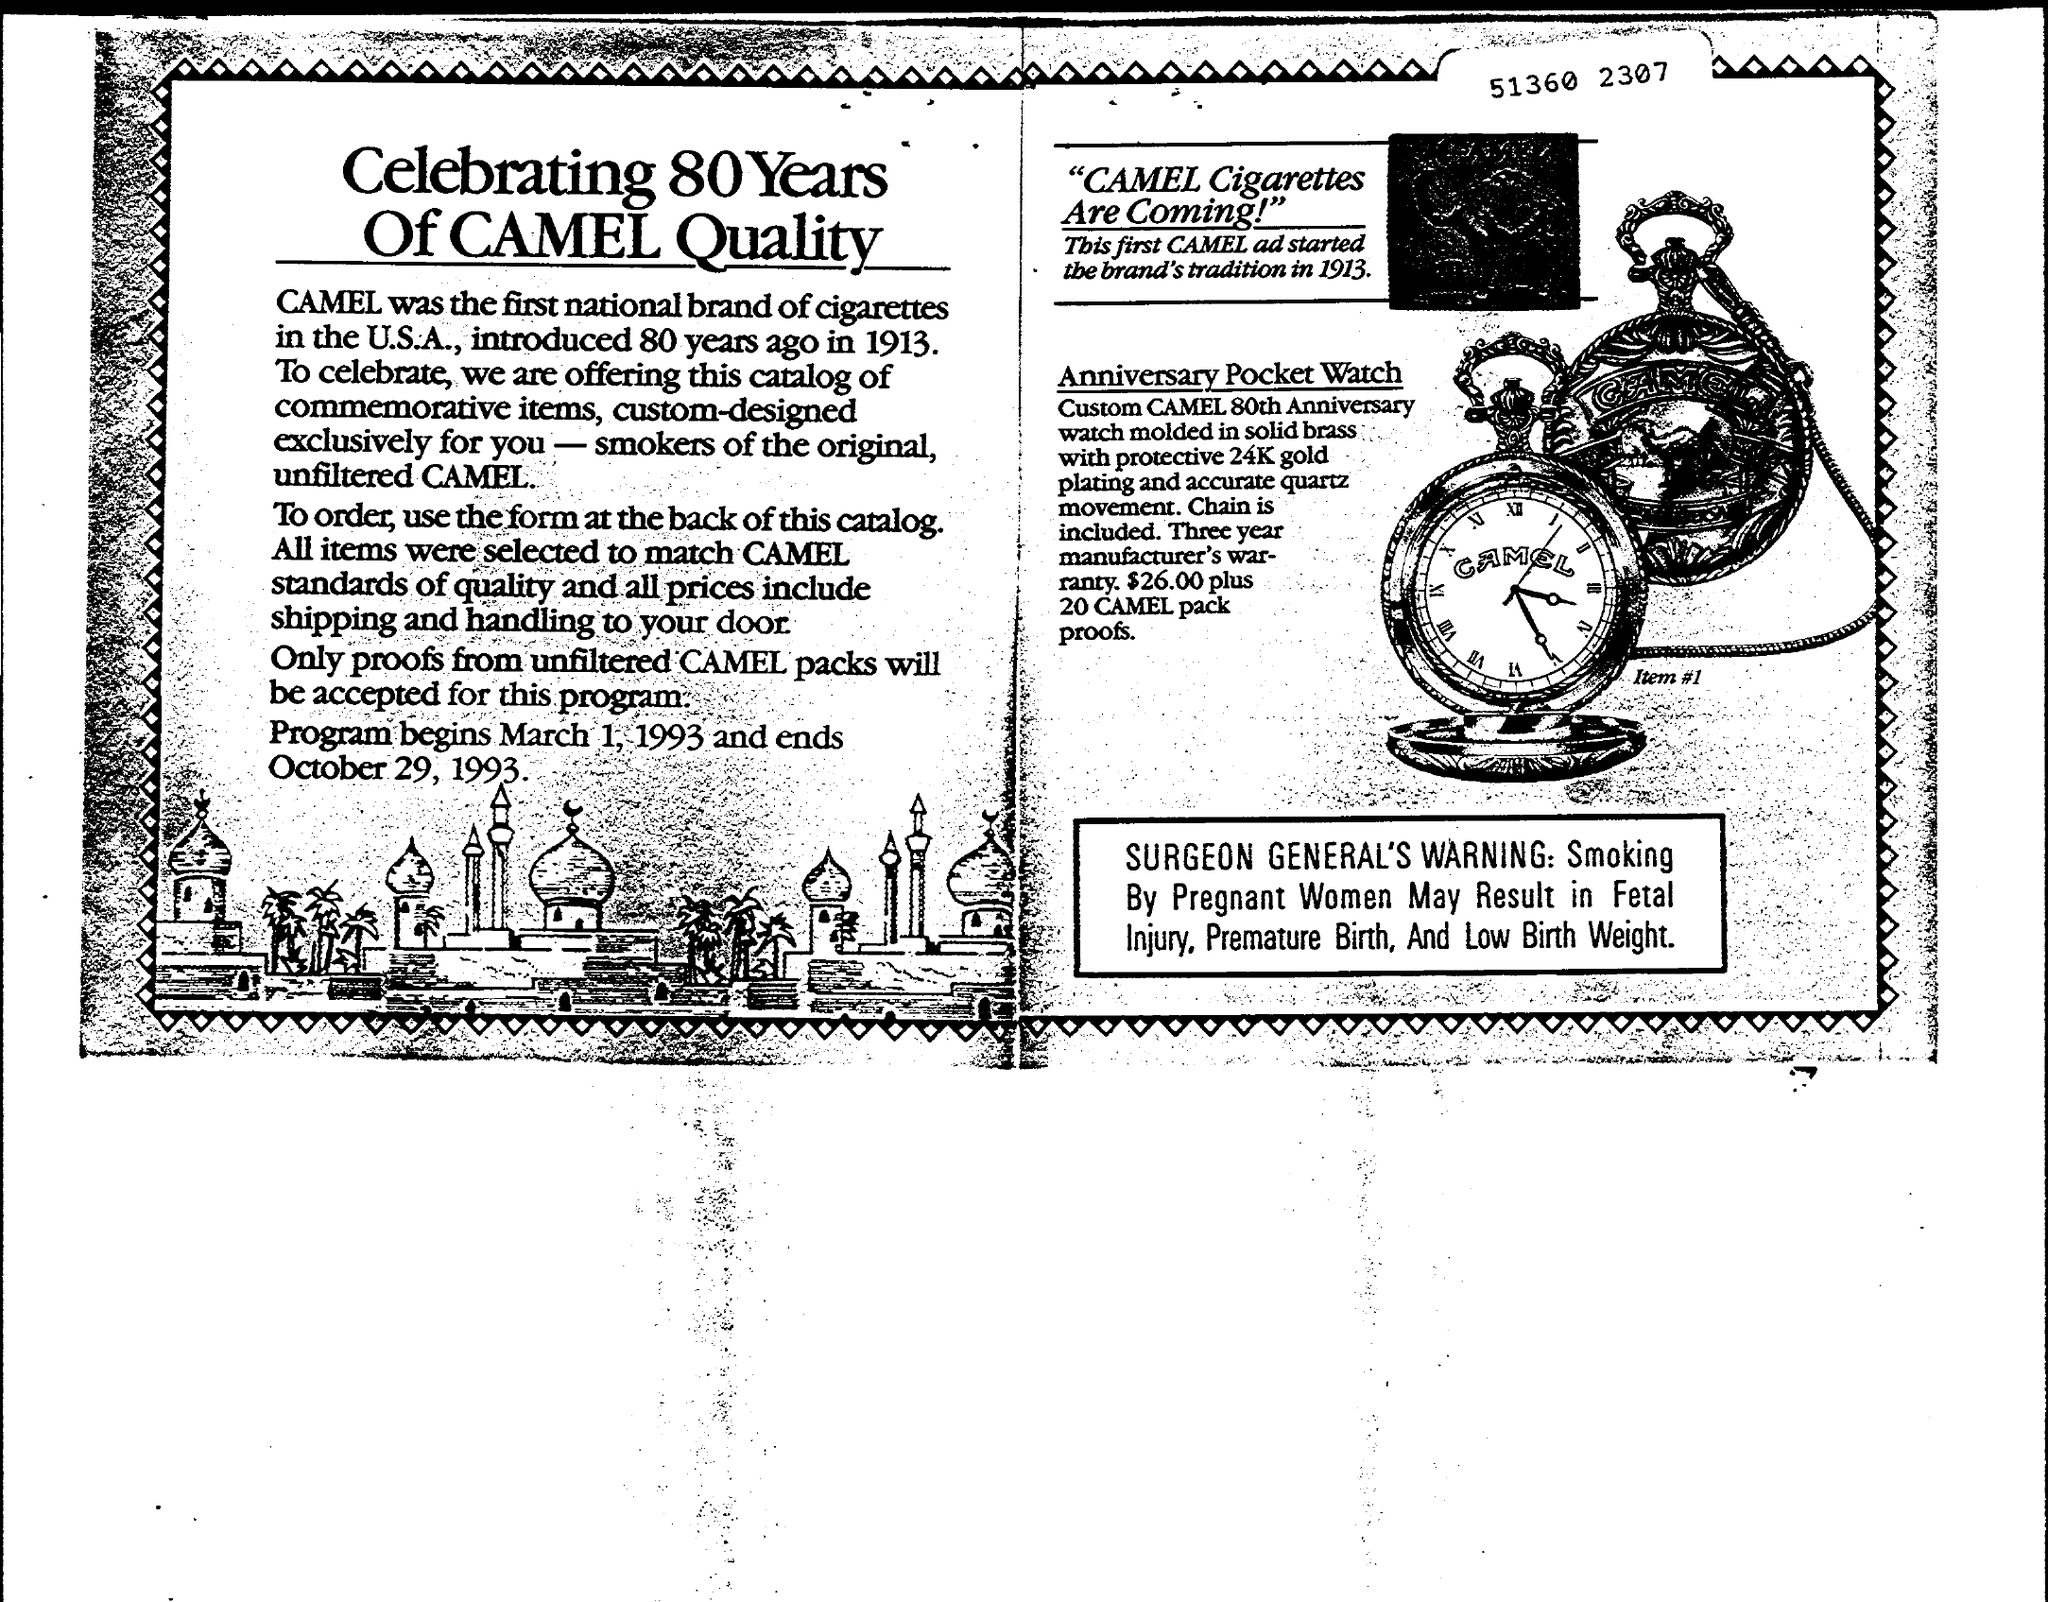When was Camel Introduced?
Your response must be concise. 1913. Which was the first national brand of cigarettes in the U.S.A.?
Provide a succinct answer. CAMEL. When does the Program begin?
Give a very brief answer. March 1, 1993. 